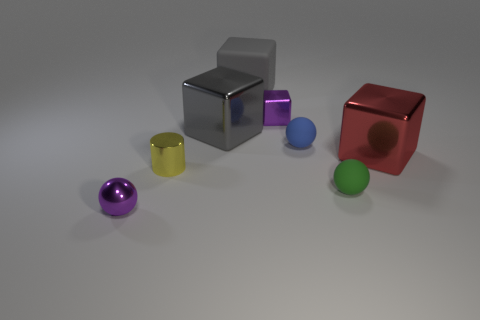What material is the tiny green thing that is the same shape as the blue object?
Offer a very short reply. Rubber. Are any small purple blocks visible?
Offer a very short reply. Yes. What shape is the big gray object that is made of the same material as the small blue ball?
Provide a short and direct response. Cube. There is a purple thing on the right side of the big rubber block; what is its material?
Your answer should be very brief. Metal. There is a tiny ball that is to the left of the large gray shiny thing; is it the same color as the tiny shiny cube?
Give a very brief answer. Yes. There is a purple thing that is behind the purple metallic thing that is in front of the large red object; how big is it?
Ensure brevity in your answer.  Small. Are there more big gray rubber cubes to the right of the tiny metal sphere than large red cylinders?
Provide a succinct answer. Yes. Is the size of the purple metal object that is behind the gray shiny cube the same as the tiny yellow metallic cylinder?
Ensure brevity in your answer.  Yes. There is a small object that is behind the yellow object and in front of the large gray shiny block; what is its color?
Give a very brief answer. Blue. What shape is the green object that is the same size as the blue sphere?
Make the answer very short. Sphere. 